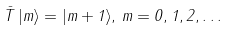<formula> <loc_0><loc_0><loc_500><loc_500>\bar { T } \, | m \rangle = | { m + 1 } \rangle , \, m = 0 , 1 , 2 , \dots \\</formula> 